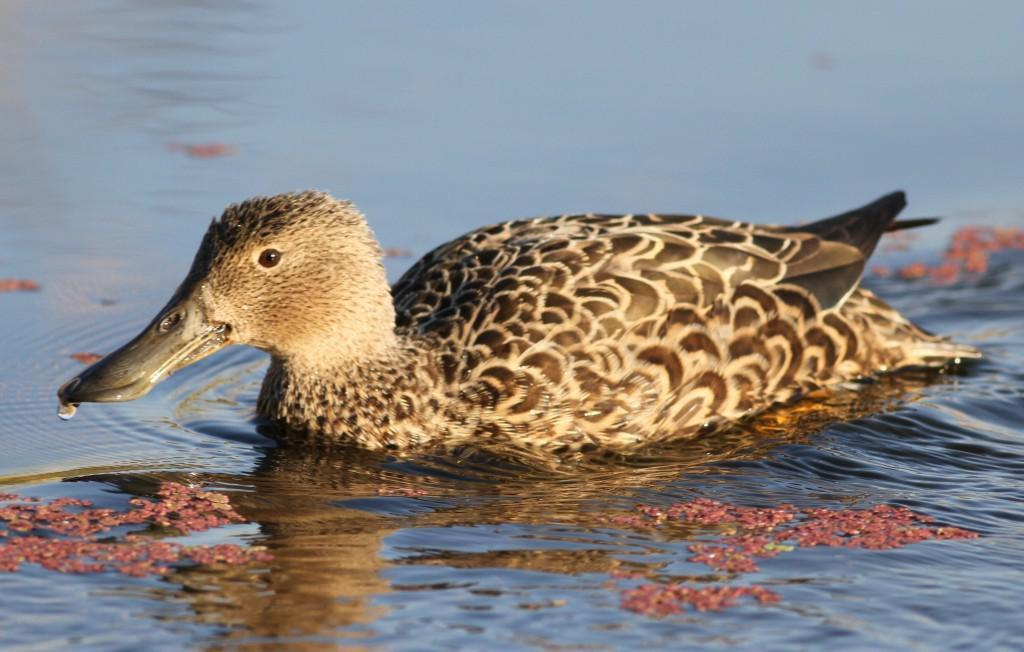What animal is present in the picture? There is a duck in the picture. What is the duck doing in the picture? The duck is swimming in the water. What color are the duck's feathers? The duck has brown feathers. What type of wine is being served on the station in the image? There is no station or wine present in the image; it features a duck swimming in the water. 